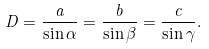<formula> <loc_0><loc_0><loc_500><loc_500>D = { \frac { a } { \sin \alpha } } = { \frac { b } { \sin \beta } } = { \frac { c } { \sin \gamma } } .</formula> 